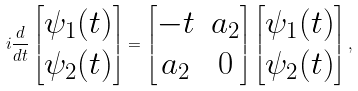<formula> <loc_0><loc_0><loc_500><loc_500>i \frac { d } { d t } \begin{bmatrix} \psi _ { 1 } ( t ) \\ \psi _ { 2 } ( t ) \end{bmatrix} = \begin{bmatrix} - t & a _ { 2 } \\ a _ { 2 } & 0 \end{bmatrix} \begin{bmatrix} \psi _ { 1 } ( t ) \\ \psi _ { 2 } ( t ) \end{bmatrix} ,</formula> 